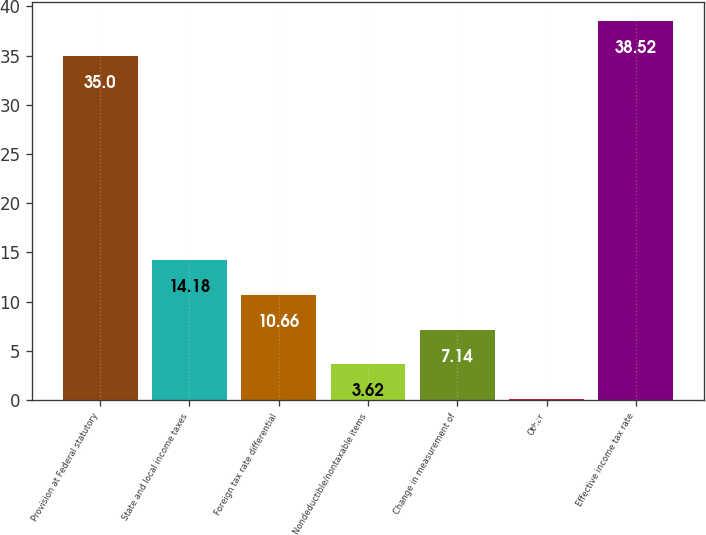Convert chart. <chart><loc_0><loc_0><loc_500><loc_500><bar_chart><fcel>Provision at Federal statutory<fcel>State and local income taxes<fcel>Foreign tax rate differential<fcel>Nondeductible/nontaxable items<fcel>Change in measurement of<fcel>Other<fcel>Effective income tax rate<nl><fcel>35<fcel>14.18<fcel>10.66<fcel>3.62<fcel>7.14<fcel>0.1<fcel>38.52<nl></chart> 